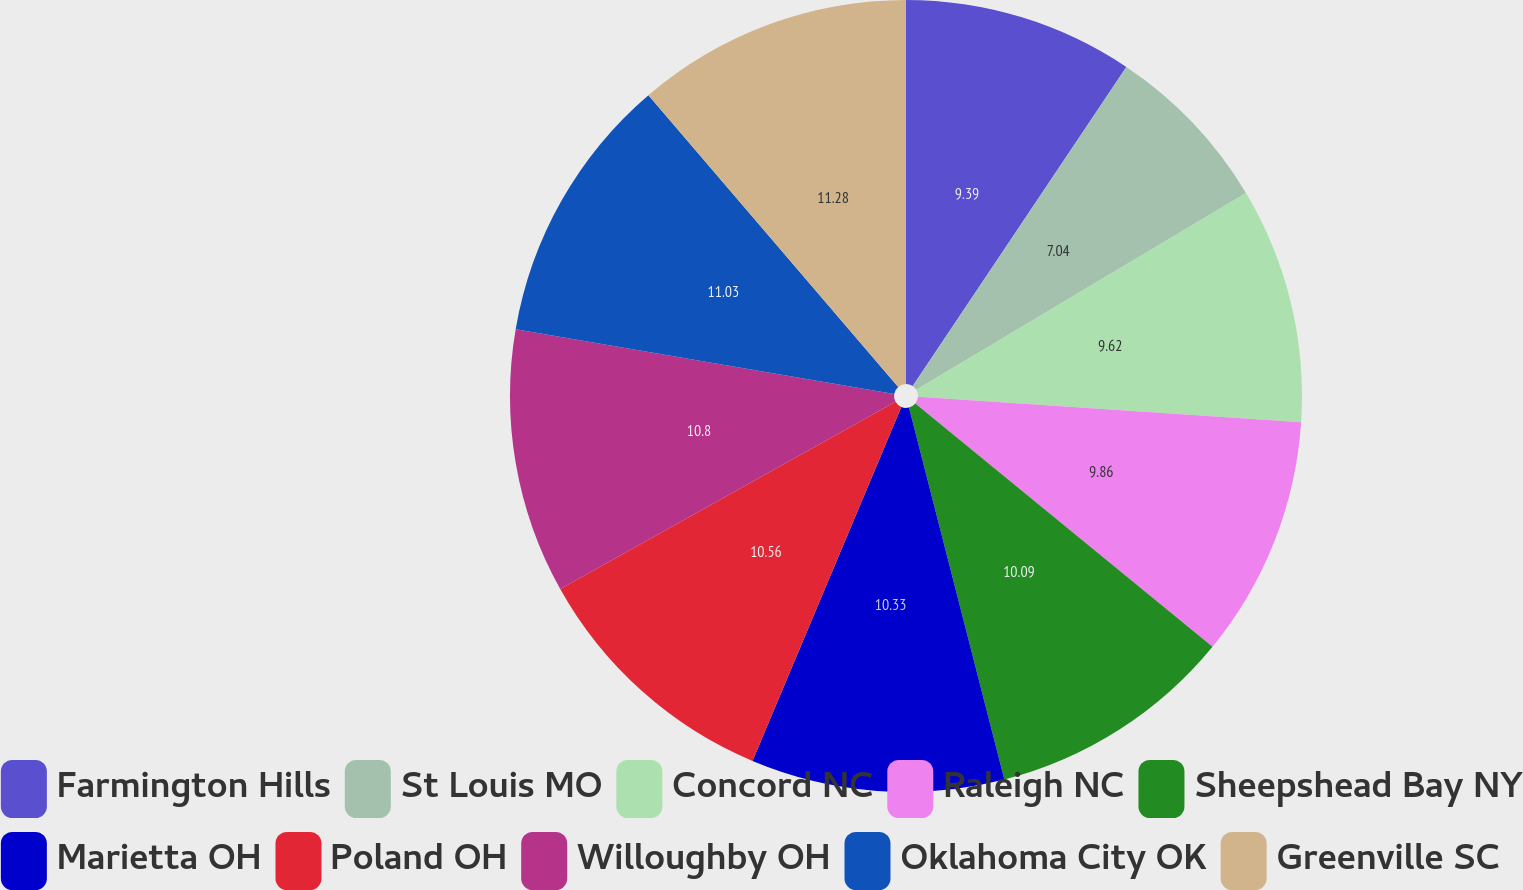Convert chart to OTSL. <chart><loc_0><loc_0><loc_500><loc_500><pie_chart><fcel>Farmington Hills<fcel>St Louis MO<fcel>Concord NC<fcel>Raleigh NC<fcel>Sheepshead Bay NY<fcel>Marietta OH<fcel>Poland OH<fcel>Willoughby OH<fcel>Oklahoma City OK<fcel>Greenville SC<nl><fcel>9.39%<fcel>7.04%<fcel>9.62%<fcel>9.86%<fcel>10.09%<fcel>10.33%<fcel>10.56%<fcel>10.8%<fcel>11.03%<fcel>11.27%<nl></chart> 